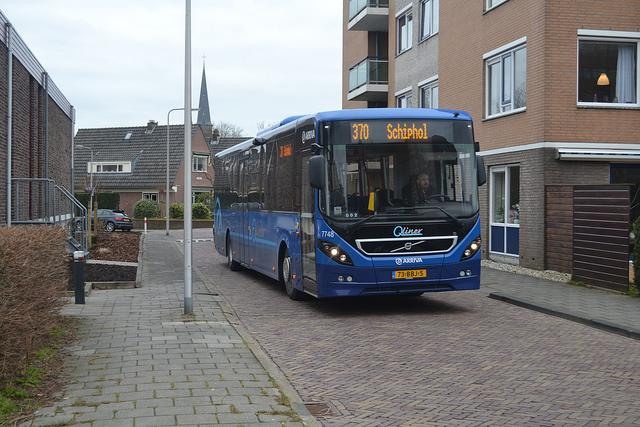What kind of problem is likely to be experienced by the apartment residents? traffic noise 